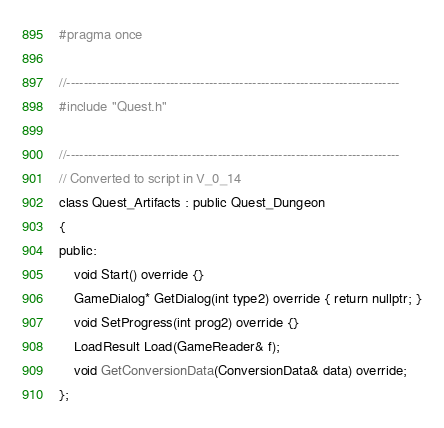<code> <loc_0><loc_0><loc_500><loc_500><_C_>#pragma once

//-----------------------------------------------------------------------------
#include "Quest.h"

//-----------------------------------------------------------------------------
// Converted to script in V_0_14
class Quest_Artifacts : public Quest_Dungeon
{
public:
	void Start() override {}
	GameDialog* GetDialog(int type2) override { return nullptr; }
	void SetProgress(int prog2) override {}
	LoadResult Load(GameReader& f);
	void GetConversionData(ConversionData& data) override;
};
</code> 